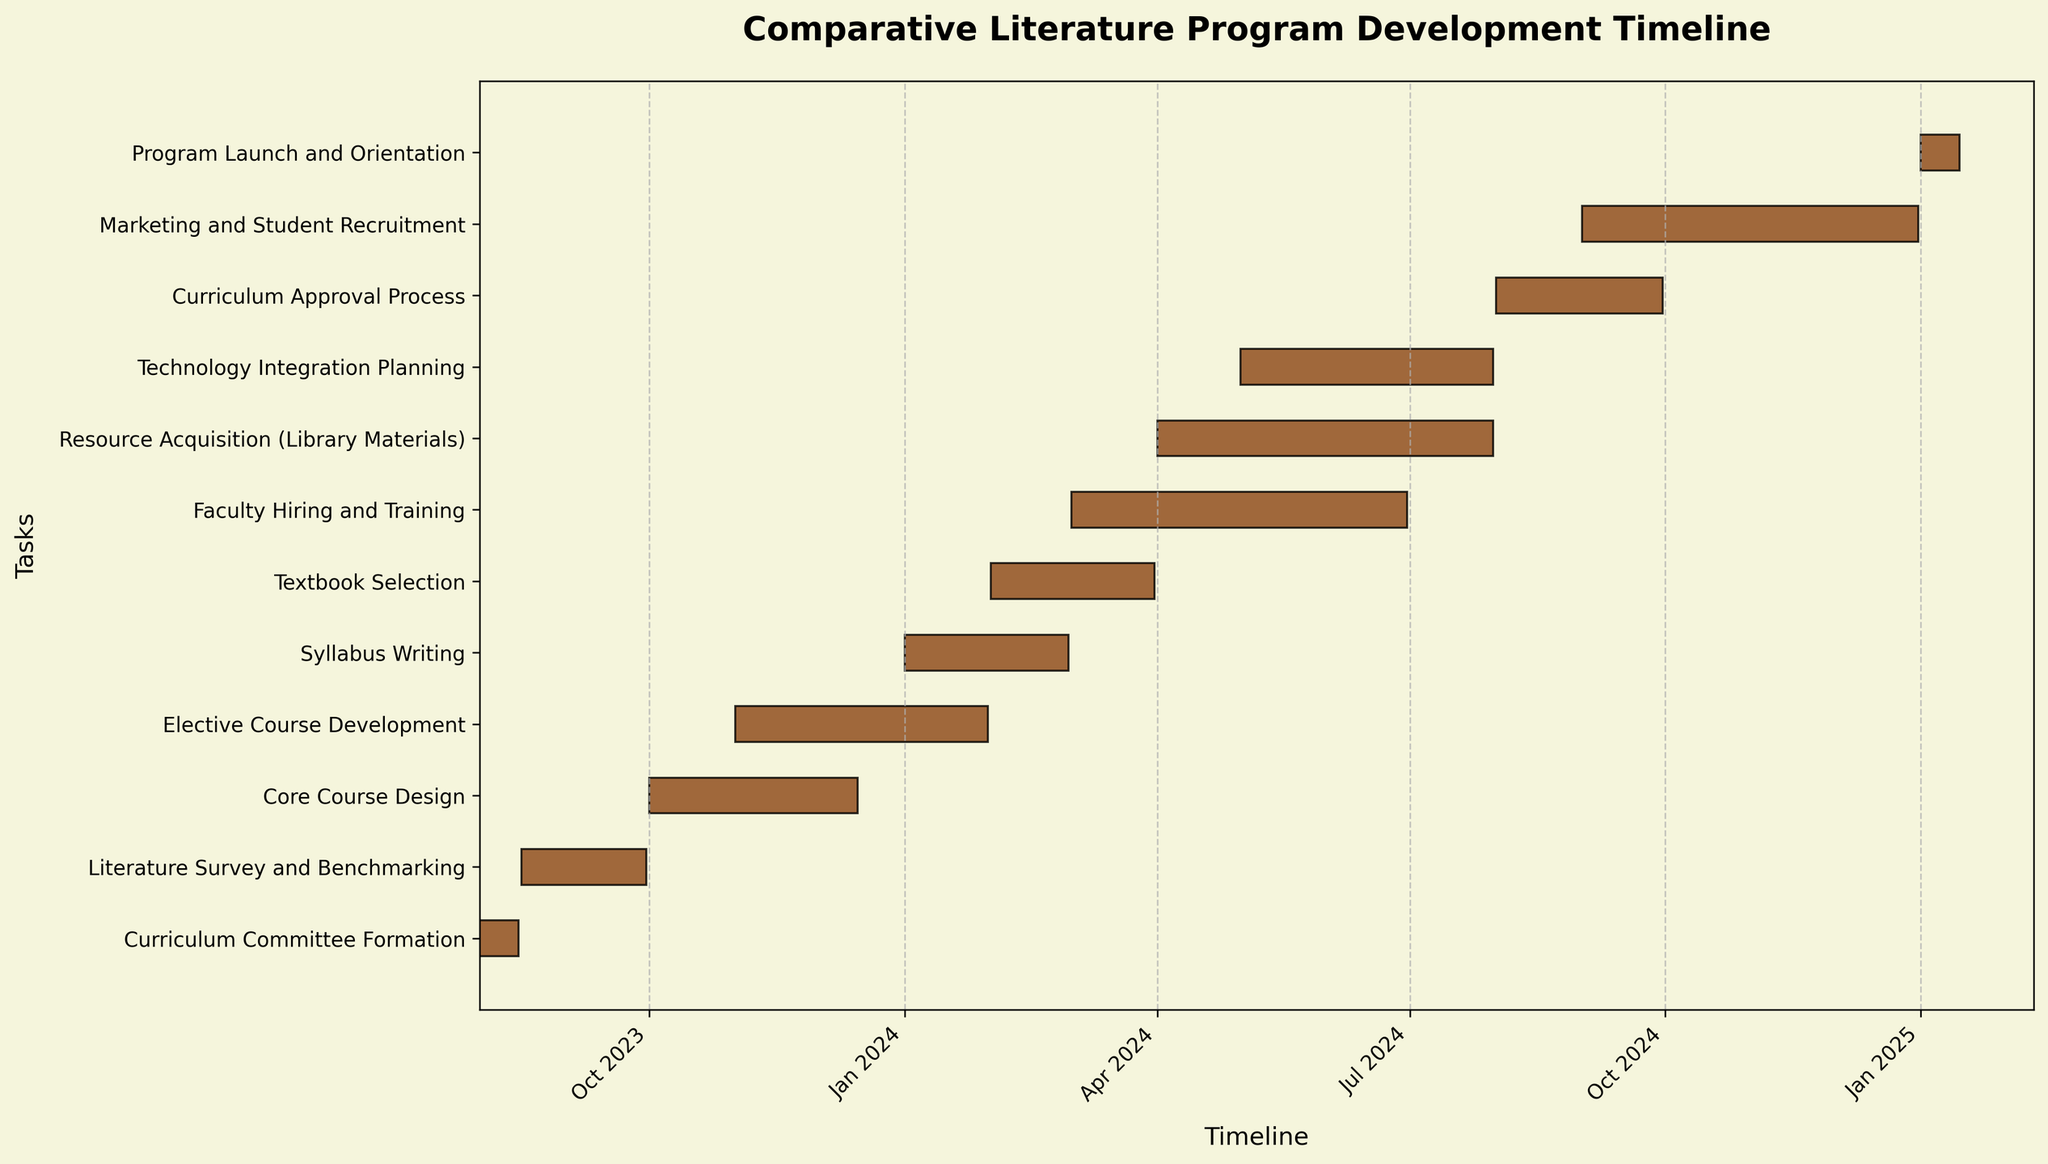What's the title of the figure? The title of the figure is usually located at the top and provides a summary of what the figure represents. In this case, it should convey the overall purpose of the Gantt Chart related to the development of the program.
Answer: Comparative Literature Program Development Timeline What does the y-axis represent? The y-axis lists the tasks involved in the development and implementation of the new comparative literature program. Each task is aligned horizontally.
Answer: Tasks How long is the "Core Course Design" phase? The "Core Course Design" phase duration can be determined by looking at the bar associated with this task and noting the dates or the given duration. It starts on 2023-10-01 and ends on 2023-12-15, which is 76 days.
Answer: 76 days Which task takes the longest duration? To find which task takes the longest duration, check the length of all bars on the chart and identify the longest one with respect to the total number of days.
Answer: Faculty Hiring and Training, Marketing and Student Recruitment, Resource Acquisition (Library Materials) (122 days each) How many tasks overlap with the "Elective Course Development"? Look at the timeline for "Elective Course Development" from 2023-11-01 to 2024-01-31 and count the number of other tasks that have bars intersecting this period. Overlapping tasks include "Core Course Design" (from 2023-10-01 to 2023-12-15) and "Syllabus Writing" (from 2024-01-01 to 2024-02-29).
Answer: 2 tasks During which months is "Textbook Selection" taking place? Locate the "Textbook Selection" task bar and check the corresponding dates on the x-axis. The task runs from 2024-02-01 to 2024-03-31.
Answer: February and March 2024 Which tasks are completed before 2024? Examine the end dates of each task to find those that finish before the beginning of 2024. They include "Curriculum Committee Formation," "Literature Survey and Benchmarking," and "Core Course Design".
Answer: Curriculum Committee Formation, Literature Survey and Benchmarking, Core Course Design Which task is shortest, and how long does it last? To find the shortest task, compare the length of the bars in the chart, and then check the duration. The "Curriculum Committee Formation" and "Program Launch and Orientation" are the shortest tasks, each lasting 15 days.
Answer: Curriculum Committee Formation and Program Launch and Orientation, 15 days Does "Technology Integration Planning" overlap with "Resource Acquisition (Library Materials)"? Check the bars for these tasks and see if their durations intersect. Both tasks start after "Resource Acquisition (Library Materials)" and span part of the same period.
Answer: Yes 